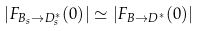<formula> <loc_0><loc_0><loc_500><loc_500>| F _ { B _ { s } \to D _ { s } ^ { * } } ( 0 ) | \simeq | F _ { B \to D ^ { * } } ( 0 ) |</formula> 